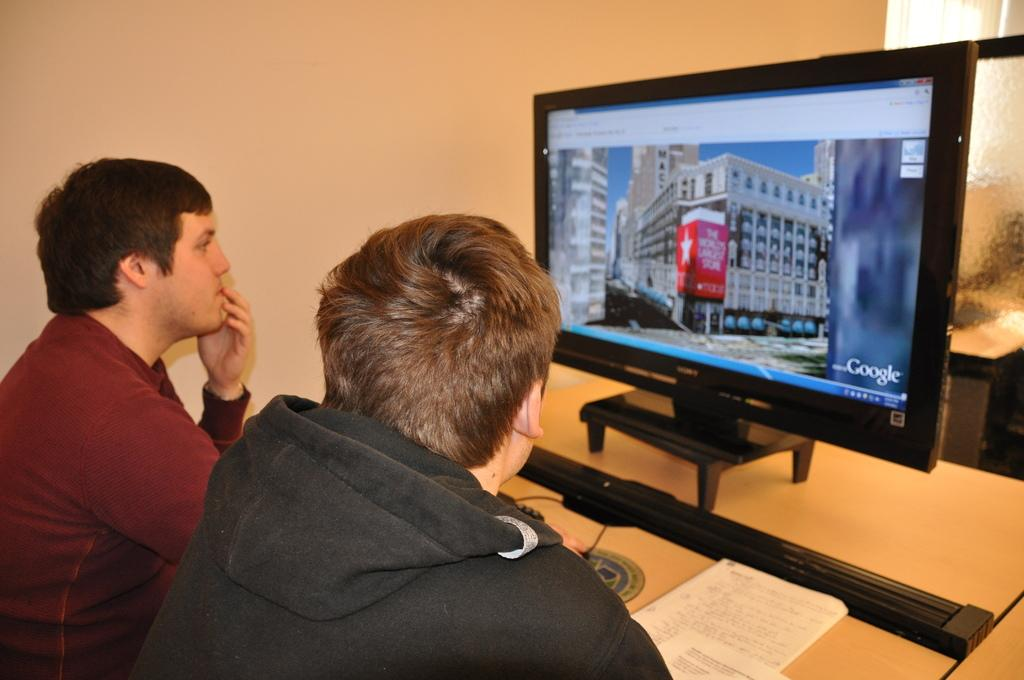<image>
Offer a succinct explanation of the picture presented. Two men are looking at a computer monitor with the google logo on the bottom right side. 